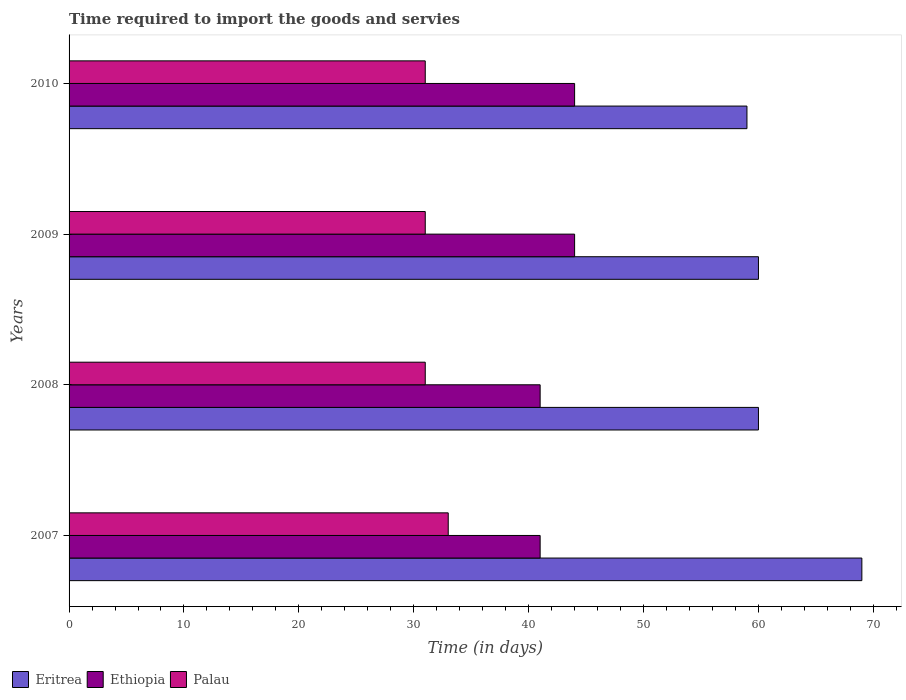How many different coloured bars are there?
Your answer should be very brief. 3. Are the number of bars per tick equal to the number of legend labels?
Offer a terse response. Yes. Are the number of bars on each tick of the Y-axis equal?
Offer a terse response. Yes. How many bars are there on the 3rd tick from the top?
Give a very brief answer. 3. What is the label of the 3rd group of bars from the top?
Make the answer very short. 2008. What is the number of days required to import the goods and services in Eritrea in 2008?
Offer a terse response. 60. Across all years, what is the maximum number of days required to import the goods and services in Ethiopia?
Offer a very short reply. 44. Across all years, what is the minimum number of days required to import the goods and services in Ethiopia?
Keep it short and to the point. 41. In which year was the number of days required to import the goods and services in Eritrea maximum?
Offer a terse response. 2007. What is the total number of days required to import the goods and services in Eritrea in the graph?
Offer a very short reply. 248. What is the difference between the number of days required to import the goods and services in Eritrea in 2009 and that in 2010?
Your answer should be compact. 1. What is the difference between the number of days required to import the goods and services in Palau in 2009 and the number of days required to import the goods and services in Eritrea in 2007?
Your answer should be compact. -38. What is the average number of days required to import the goods and services in Palau per year?
Provide a short and direct response. 31.5. In the year 2009, what is the difference between the number of days required to import the goods and services in Eritrea and number of days required to import the goods and services in Palau?
Offer a terse response. 29. What is the ratio of the number of days required to import the goods and services in Ethiopia in 2008 to that in 2009?
Your response must be concise. 0.93. Is the difference between the number of days required to import the goods and services in Eritrea in 2007 and 2009 greater than the difference between the number of days required to import the goods and services in Palau in 2007 and 2009?
Keep it short and to the point. Yes. What is the difference between the highest and the second highest number of days required to import the goods and services in Eritrea?
Your answer should be compact. 9. What is the difference between the highest and the lowest number of days required to import the goods and services in Eritrea?
Provide a succinct answer. 10. Is the sum of the number of days required to import the goods and services in Palau in 2008 and 2009 greater than the maximum number of days required to import the goods and services in Eritrea across all years?
Keep it short and to the point. No. What does the 1st bar from the top in 2008 represents?
Provide a short and direct response. Palau. What does the 1st bar from the bottom in 2010 represents?
Your answer should be compact. Eritrea. What is the difference between two consecutive major ticks on the X-axis?
Your response must be concise. 10. Does the graph contain any zero values?
Offer a very short reply. No. Does the graph contain grids?
Your answer should be compact. No. How are the legend labels stacked?
Give a very brief answer. Horizontal. What is the title of the graph?
Your answer should be compact. Time required to import the goods and servies. What is the label or title of the X-axis?
Offer a terse response. Time (in days). What is the Time (in days) in Palau in 2008?
Keep it short and to the point. 31. What is the Time (in days) of Ethiopia in 2009?
Keep it short and to the point. 44. What is the Time (in days) in Palau in 2009?
Provide a succinct answer. 31. What is the Time (in days) in Eritrea in 2010?
Make the answer very short. 59. Across all years, what is the maximum Time (in days) of Ethiopia?
Your answer should be compact. 44. Across all years, what is the maximum Time (in days) of Palau?
Your answer should be compact. 33. Across all years, what is the minimum Time (in days) in Ethiopia?
Provide a short and direct response. 41. Across all years, what is the minimum Time (in days) of Palau?
Ensure brevity in your answer.  31. What is the total Time (in days) of Eritrea in the graph?
Offer a terse response. 248. What is the total Time (in days) of Ethiopia in the graph?
Ensure brevity in your answer.  170. What is the total Time (in days) in Palau in the graph?
Provide a short and direct response. 126. What is the difference between the Time (in days) of Eritrea in 2007 and that in 2008?
Offer a very short reply. 9. What is the difference between the Time (in days) in Ethiopia in 2007 and that in 2010?
Offer a very short reply. -3. What is the difference between the Time (in days) in Eritrea in 2008 and that in 2009?
Offer a terse response. 0. What is the difference between the Time (in days) in Eritrea in 2008 and that in 2010?
Provide a short and direct response. 1. What is the difference between the Time (in days) of Ethiopia in 2008 and that in 2010?
Your response must be concise. -3. What is the difference between the Time (in days) of Palau in 2008 and that in 2010?
Your response must be concise. 0. What is the difference between the Time (in days) in Ethiopia in 2009 and that in 2010?
Keep it short and to the point. 0. What is the difference between the Time (in days) of Palau in 2009 and that in 2010?
Keep it short and to the point. 0. What is the difference between the Time (in days) of Eritrea in 2007 and the Time (in days) of Palau in 2008?
Keep it short and to the point. 38. What is the difference between the Time (in days) of Eritrea in 2007 and the Time (in days) of Palau in 2009?
Offer a very short reply. 38. What is the difference between the Time (in days) of Eritrea in 2007 and the Time (in days) of Ethiopia in 2010?
Your response must be concise. 25. What is the difference between the Time (in days) of Eritrea in 2007 and the Time (in days) of Palau in 2010?
Give a very brief answer. 38. What is the difference between the Time (in days) in Ethiopia in 2007 and the Time (in days) in Palau in 2010?
Your answer should be very brief. 10. What is the difference between the Time (in days) of Eritrea in 2008 and the Time (in days) of Palau in 2009?
Offer a terse response. 29. What is the difference between the Time (in days) of Ethiopia in 2008 and the Time (in days) of Palau in 2009?
Make the answer very short. 10. What is the difference between the Time (in days) of Eritrea in 2008 and the Time (in days) of Ethiopia in 2010?
Your response must be concise. 16. What is the difference between the Time (in days) of Eritrea in 2008 and the Time (in days) of Palau in 2010?
Keep it short and to the point. 29. What is the average Time (in days) in Ethiopia per year?
Provide a short and direct response. 42.5. What is the average Time (in days) in Palau per year?
Keep it short and to the point. 31.5. In the year 2007, what is the difference between the Time (in days) of Eritrea and Time (in days) of Ethiopia?
Offer a terse response. 28. In the year 2007, what is the difference between the Time (in days) of Eritrea and Time (in days) of Palau?
Your answer should be very brief. 36. In the year 2008, what is the difference between the Time (in days) in Eritrea and Time (in days) in Ethiopia?
Your answer should be compact. 19. In the year 2008, what is the difference between the Time (in days) in Ethiopia and Time (in days) in Palau?
Your answer should be very brief. 10. In the year 2009, what is the difference between the Time (in days) in Eritrea and Time (in days) in Ethiopia?
Provide a succinct answer. 16. In the year 2009, what is the difference between the Time (in days) in Ethiopia and Time (in days) in Palau?
Offer a terse response. 13. In the year 2010, what is the difference between the Time (in days) in Eritrea and Time (in days) in Palau?
Give a very brief answer. 28. In the year 2010, what is the difference between the Time (in days) in Ethiopia and Time (in days) in Palau?
Your response must be concise. 13. What is the ratio of the Time (in days) of Eritrea in 2007 to that in 2008?
Make the answer very short. 1.15. What is the ratio of the Time (in days) in Ethiopia in 2007 to that in 2008?
Your answer should be compact. 1. What is the ratio of the Time (in days) in Palau in 2007 to that in 2008?
Provide a succinct answer. 1.06. What is the ratio of the Time (in days) in Eritrea in 2007 to that in 2009?
Ensure brevity in your answer.  1.15. What is the ratio of the Time (in days) in Ethiopia in 2007 to that in 2009?
Your response must be concise. 0.93. What is the ratio of the Time (in days) in Palau in 2007 to that in 2009?
Ensure brevity in your answer.  1.06. What is the ratio of the Time (in days) of Eritrea in 2007 to that in 2010?
Offer a terse response. 1.17. What is the ratio of the Time (in days) in Ethiopia in 2007 to that in 2010?
Your response must be concise. 0.93. What is the ratio of the Time (in days) in Palau in 2007 to that in 2010?
Your answer should be compact. 1.06. What is the ratio of the Time (in days) of Eritrea in 2008 to that in 2009?
Offer a terse response. 1. What is the ratio of the Time (in days) of Ethiopia in 2008 to that in 2009?
Your answer should be compact. 0.93. What is the ratio of the Time (in days) in Eritrea in 2008 to that in 2010?
Make the answer very short. 1.02. What is the ratio of the Time (in days) in Ethiopia in 2008 to that in 2010?
Your answer should be very brief. 0.93. What is the ratio of the Time (in days) in Palau in 2008 to that in 2010?
Offer a very short reply. 1. What is the ratio of the Time (in days) of Eritrea in 2009 to that in 2010?
Your response must be concise. 1.02. What is the ratio of the Time (in days) in Palau in 2009 to that in 2010?
Your answer should be very brief. 1. What is the difference between the highest and the lowest Time (in days) of Eritrea?
Offer a terse response. 10. What is the difference between the highest and the lowest Time (in days) of Ethiopia?
Offer a terse response. 3. 